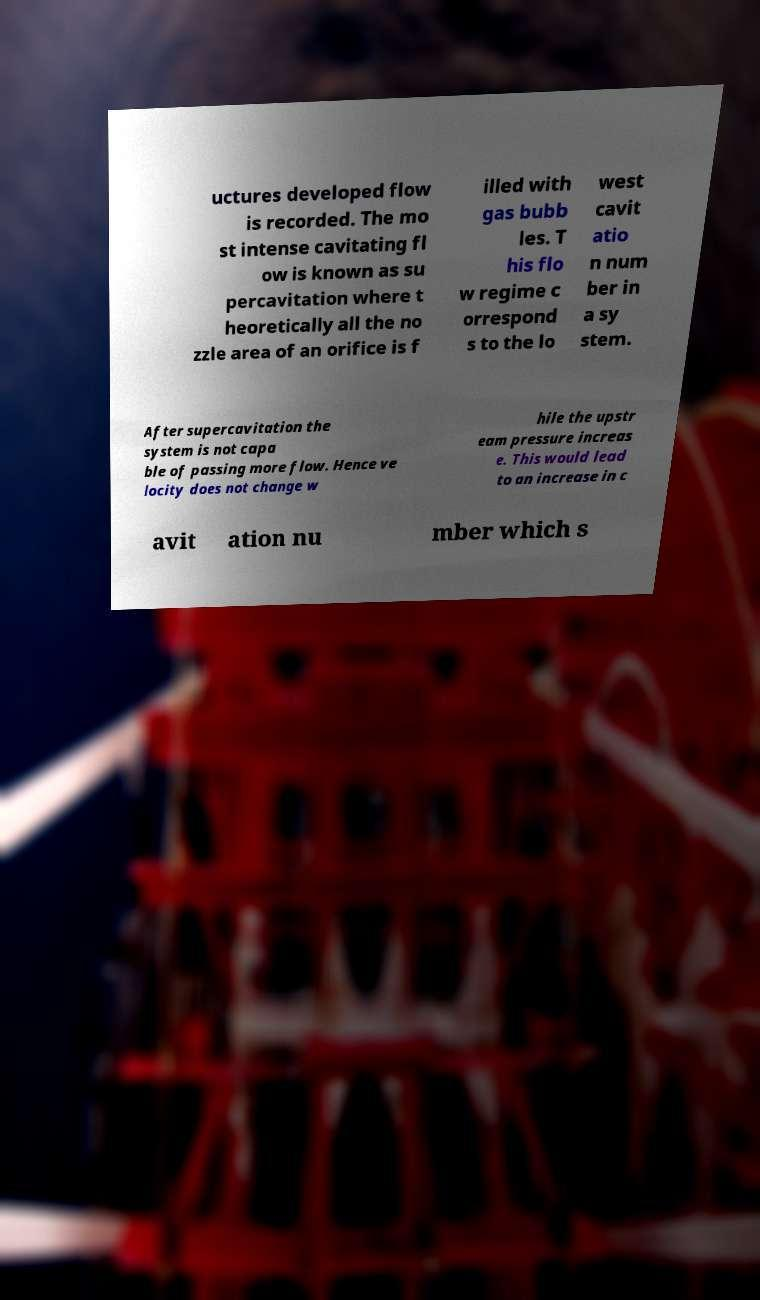Please read and relay the text visible in this image. What does it say? uctures developed flow is recorded. The mo st intense cavitating fl ow is known as su percavitation where t heoretically all the no zzle area of an orifice is f illed with gas bubb les. T his flo w regime c orrespond s to the lo west cavit atio n num ber in a sy stem. After supercavitation the system is not capa ble of passing more flow. Hence ve locity does not change w hile the upstr eam pressure increas e. This would lead to an increase in c avit ation nu mber which s 